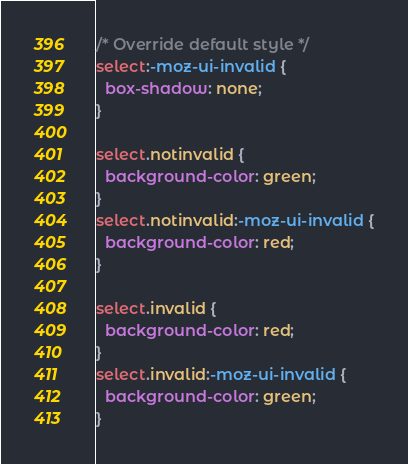Convert code to text. <code><loc_0><loc_0><loc_500><loc_500><_CSS_>/* Override default style */
select:-moz-ui-invalid {
  box-shadow: none;
}

select.notinvalid {
  background-color: green;
}
select.notinvalid:-moz-ui-invalid {
  background-color: red;
}

select.invalid {
  background-color: red;
}
select.invalid:-moz-ui-invalid {
  background-color: green;
}
</code> 